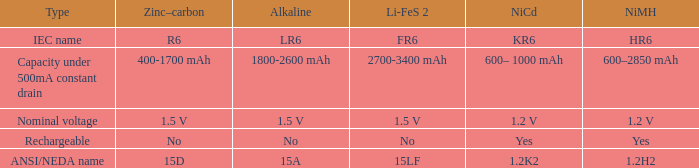What is Li-FeS 2, when Type is Nominal Voltage? 1.5 V. 